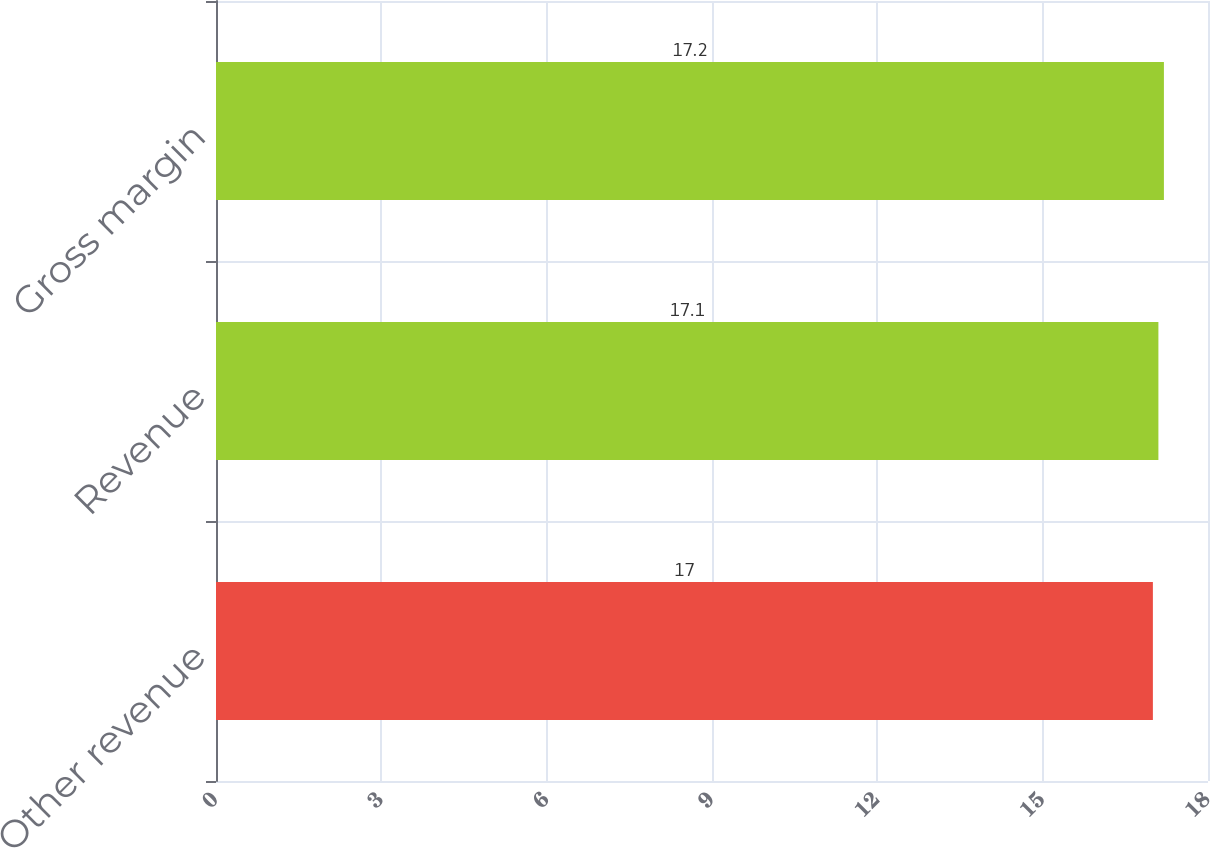<chart> <loc_0><loc_0><loc_500><loc_500><bar_chart><fcel>Other revenue<fcel>Revenue<fcel>Gross margin<nl><fcel>17<fcel>17.1<fcel>17.2<nl></chart> 